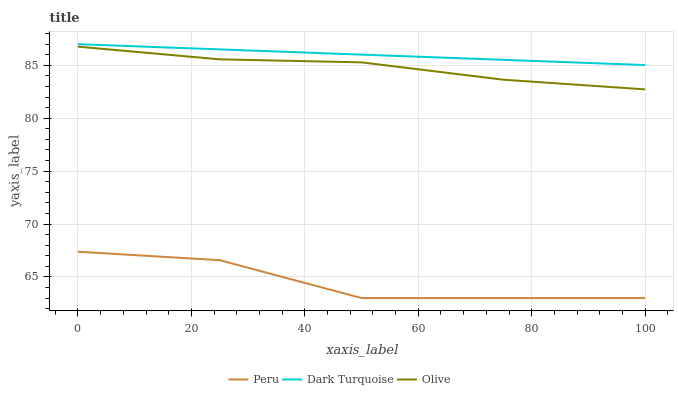Does Peru have the minimum area under the curve?
Answer yes or no. Yes. Does Dark Turquoise have the maximum area under the curve?
Answer yes or no. Yes. Does Dark Turquoise have the minimum area under the curve?
Answer yes or no. No. Does Peru have the maximum area under the curve?
Answer yes or no. No. Is Dark Turquoise the smoothest?
Answer yes or no. Yes. Is Peru the roughest?
Answer yes or no. Yes. Is Peru the smoothest?
Answer yes or no. No. Is Dark Turquoise the roughest?
Answer yes or no. No. Does Peru have the lowest value?
Answer yes or no. Yes. Does Dark Turquoise have the lowest value?
Answer yes or no. No. Does Dark Turquoise have the highest value?
Answer yes or no. Yes. Does Peru have the highest value?
Answer yes or no. No. Is Olive less than Dark Turquoise?
Answer yes or no. Yes. Is Dark Turquoise greater than Olive?
Answer yes or no. Yes. Does Olive intersect Dark Turquoise?
Answer yes or no. No. 